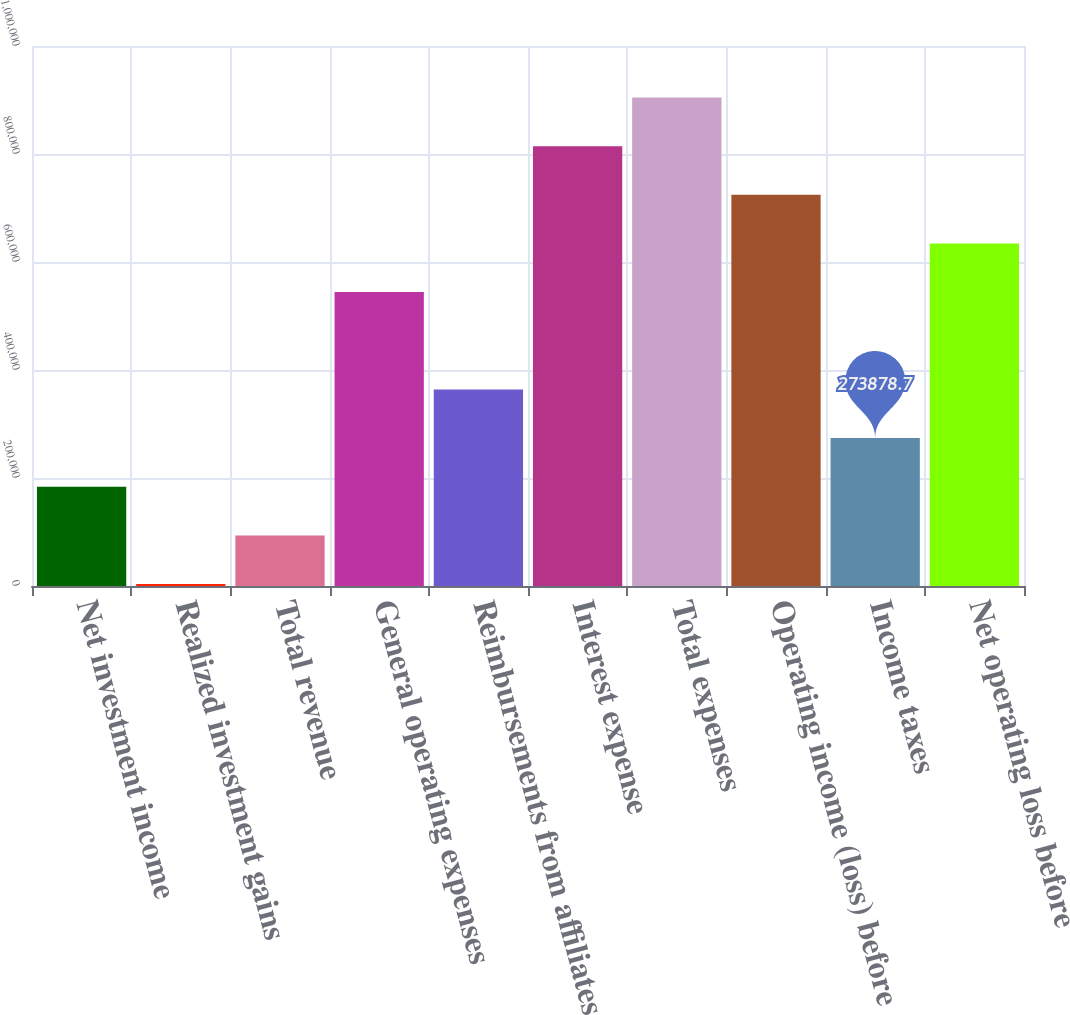Convert chart to OTSL. <chart><loc_0><loc_0><loc_500><loc_500><bar_chart><fcel>Net investment income<fcel>Realized investment gains<fcel>Total revenue<fcel>General operating expenses<fcel>Reimbursements from affiliates<fcel>Interest expense<fcel>Total expenses<fcel>Operating income (loss) before<fcel>Income taxes<fcel>Net operating loss before<nl><fcel>183764<fcel>3534<fcel>93648.9<fcel>544223<fcel>363994<fcel>814568<fcel>904683<fcel>724453<fcel>273879<fcel>634338<nl></chart> 